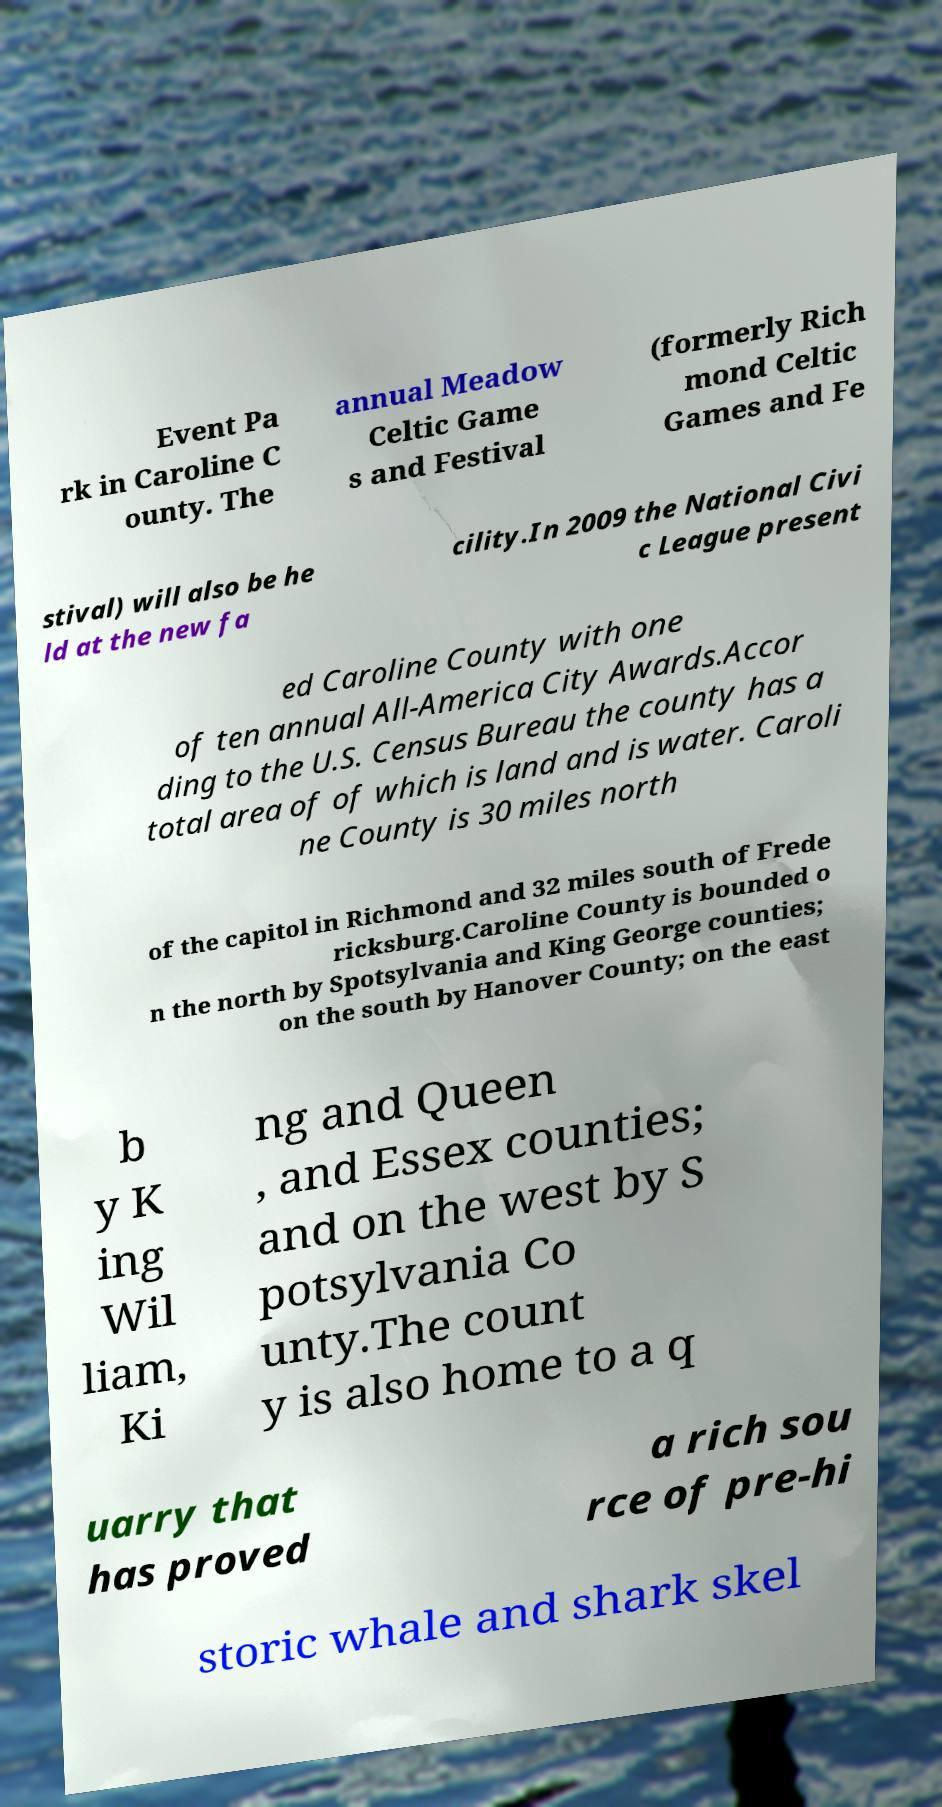Can you accurately transcribe the text from the provided image for me? Event Pa rk in Caroline C ounty. The annual Meadow Celtic Game s and Festival (formerly Rich mond Celtic Games and Fe stival) will also be he ld at the new fa cility.In 2009 the National Civi c League present ed Caroline County with one of ten annual All-America City Awards.Accor ding to the U.S. Census Bureau the county has a total area of of which is land and is water. Caroli ne County is 30 miles north of the capitol in Richmond and 32 miles south of Frede ricksburg.Caroline County is bounded o n the north by Spotsylvania and King George counties; on the south by Hanover County; on the east b y K ing Wil liam, Ki ng and Queen , and Essex counties; and on the west by S potsylvania Co unty.The count y is also home to a q uarry that has proved a rich sou rce of pre-hi storic whale and shark skel 